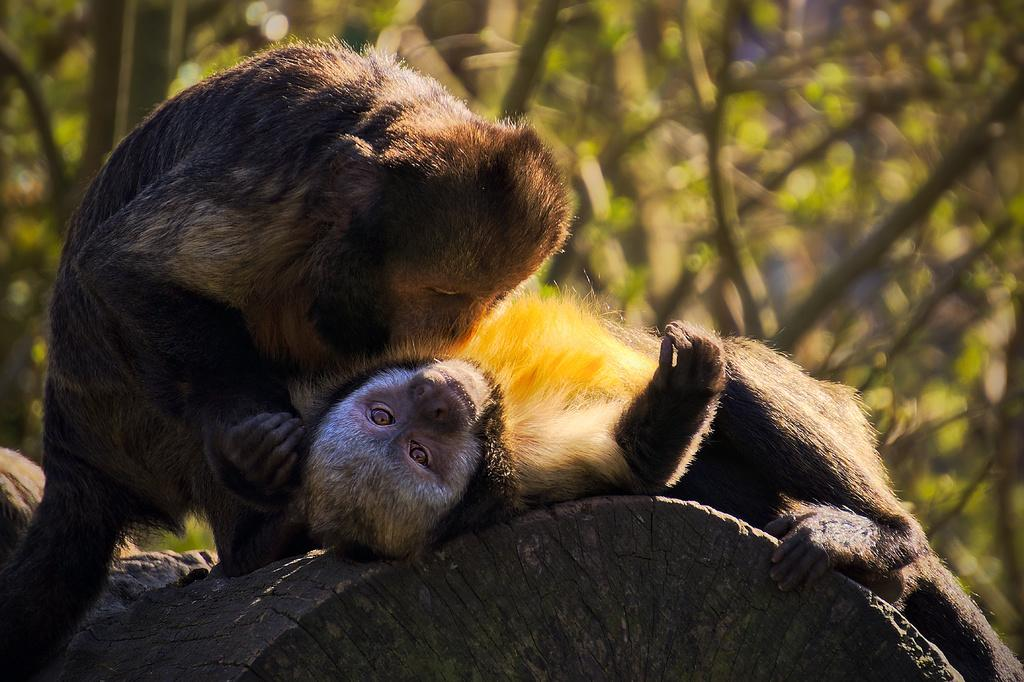What is the main subject of the image? The main subject of the image is animals on a tree trunk. Can you describe the background of the image? The background of the image is blurry. What type of sound can be heard coming from the animals in the image? There is no sound present in the image, as it is a still photograph. What hobbies do the animals on the tree trunk have? The image does not provide information about the animals' hobbies, as it only shows them on the tree trunk. 